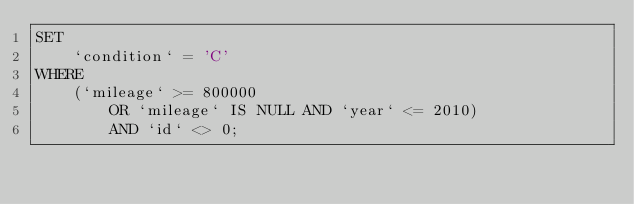<code> <loc_0><loc_0><loc_500><loc_500><_SQL_>SET 
    `condition` = 'C'
WHERE
    (`mileage` >= 800000
        OR `mileage` IS NULL AND `year` <= 2010)
        AND `id` <> 0;


</code> 